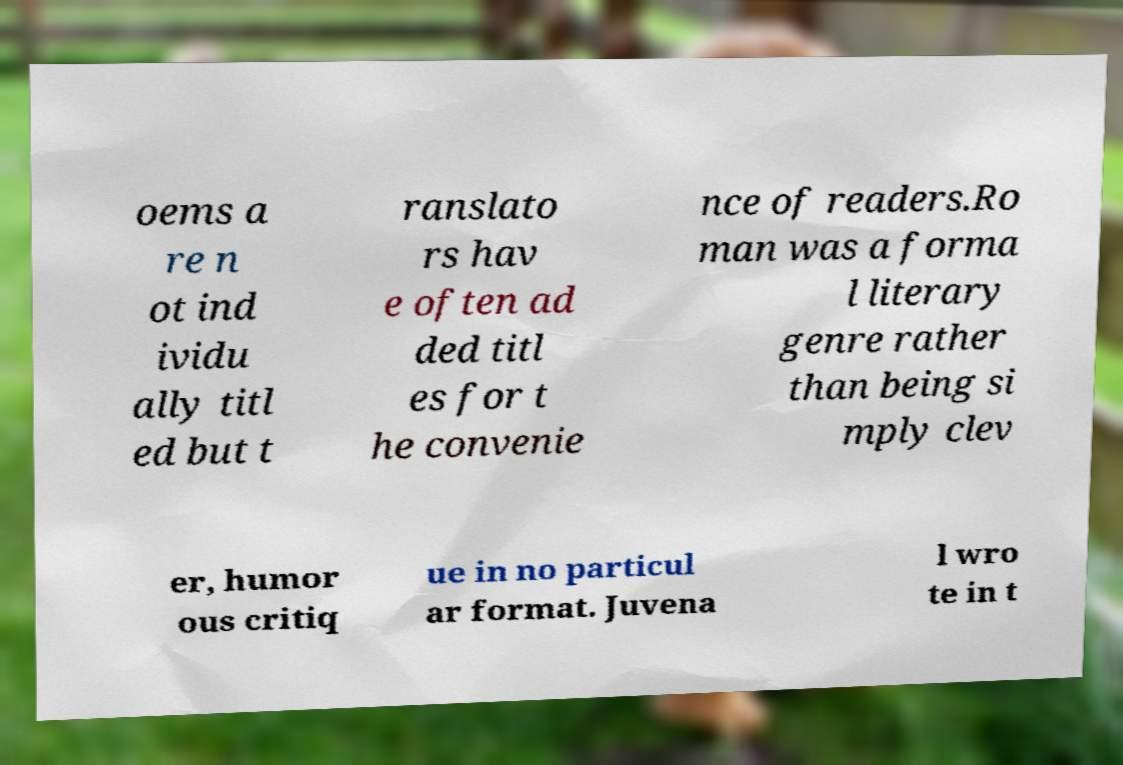Could you extract and type out the text from this image? oems a re n ot ind ividu ally titl ed but t ranslato rs hav e often ad ded titl es for t he convenie nce of readers.Ro man was a forma l literary genre rather than being si mply clev er, humor ous critiq ue in no particul ar format. Juvena l wro te in t 